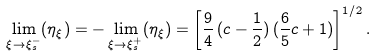Convert formula to latex. <formula><loc_0><loc_0><loc_500><loc_500>\lim _ { \xi \to \xi _ { s } ^ { - } } ( \eta _ { \xi } ) = - \lim _ { \xi \to \xi _ { s } ^ { + } } ( \eta _ { \xi } ) = \left [ \frac { 9 } { 4 } \, ( c - \frac { 1 } { 2 } ) \, ( \frac { 6 } { 5 } c + 1 ) \right ] ^ { 1 / 2 } .</formula> 